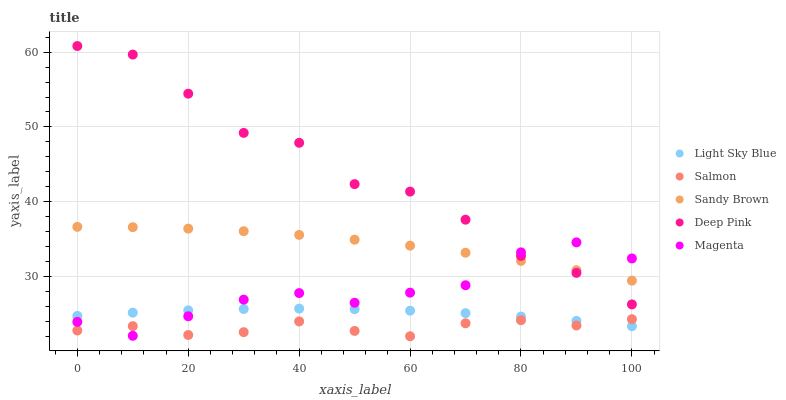Does Salmon have the minimum area under the curve?
Answer yes or no. Yes. Does Deep Pink have the maximum area under the curve?
Answer yes or no. Yes. Does Magenta have the minimum area under the curve?
Answer yes or no. No. Does Magenta have the maximum area under the curve?
Answer yes or no. No. Is Light Sky Blue the smoothest?
Answer yes or no. Yes. Is Deep Pink the roughest?
Answer yes or no. Yes. Is Magenta the smoothest?
Answer yes or no. No. Is Magenta the roughest?
Answer yes or no. No. Does Salmon have the lowest value?
Answer yes or no. Yes. Does Magenta have the lowest value?
Answer yes or no. No. Does Deep Pink have the highest value?
Answer yes or no. Yes. Does Magenta have the highest value?
Answer yes or no. No. Is Salmon less than Sandy Brown?
Answer yes or no. Yes. Is Sandy Brown greater than Light Sky Blue?
Answer yes or no. Yes. Does Sandy Brown intersect Magenta?
Answer yes or no. Yes. Is Sandy Brown less than Magenta?
Answer yes or no. No. Is Sandy Brown greater than Magenta?
Answer yes or no. No. Does Salmon intersect Sandy Brown?
Answer yes or no. No. 